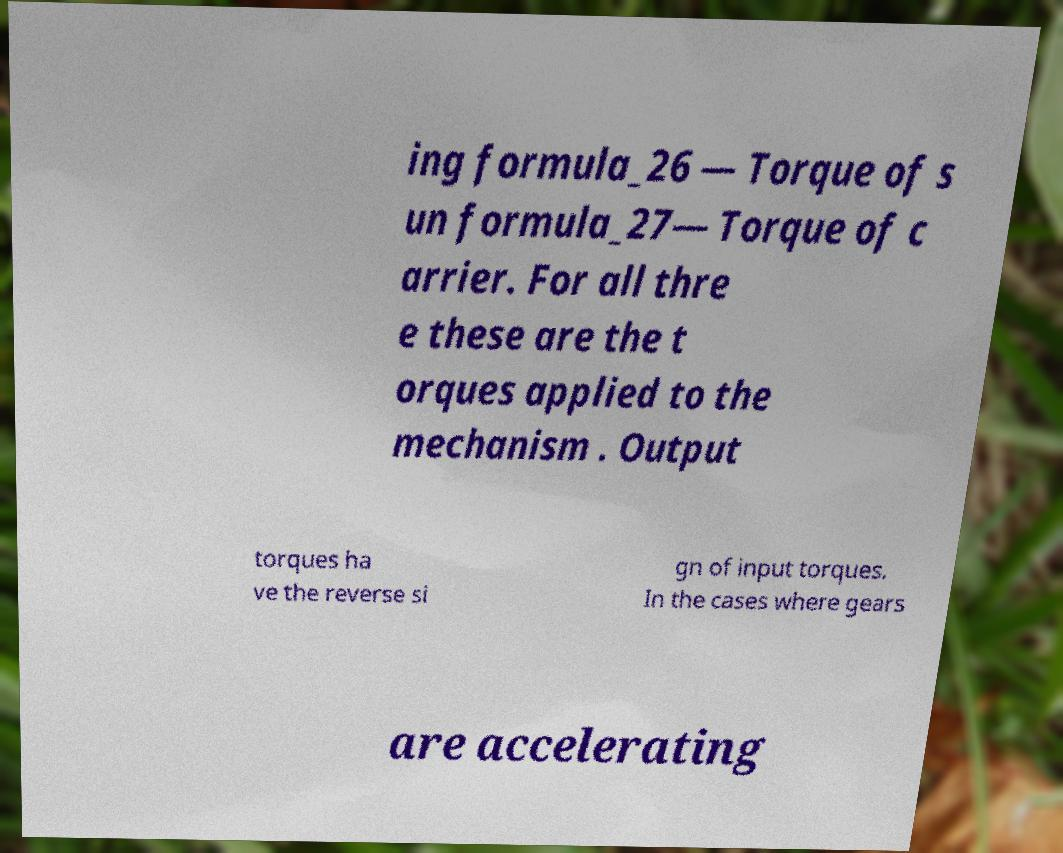Can you read and provide the text displayed in the image?This photo seems to have some interesting text. Can you extract and type it out for me? ing formula_26 — Torque of s un formula_27— Torque of c arrier. For all thre e these are the t orques applied to the mechanism . Output torques ha ve the reverse si gn of input torques. In the cases where gears are accelerating 